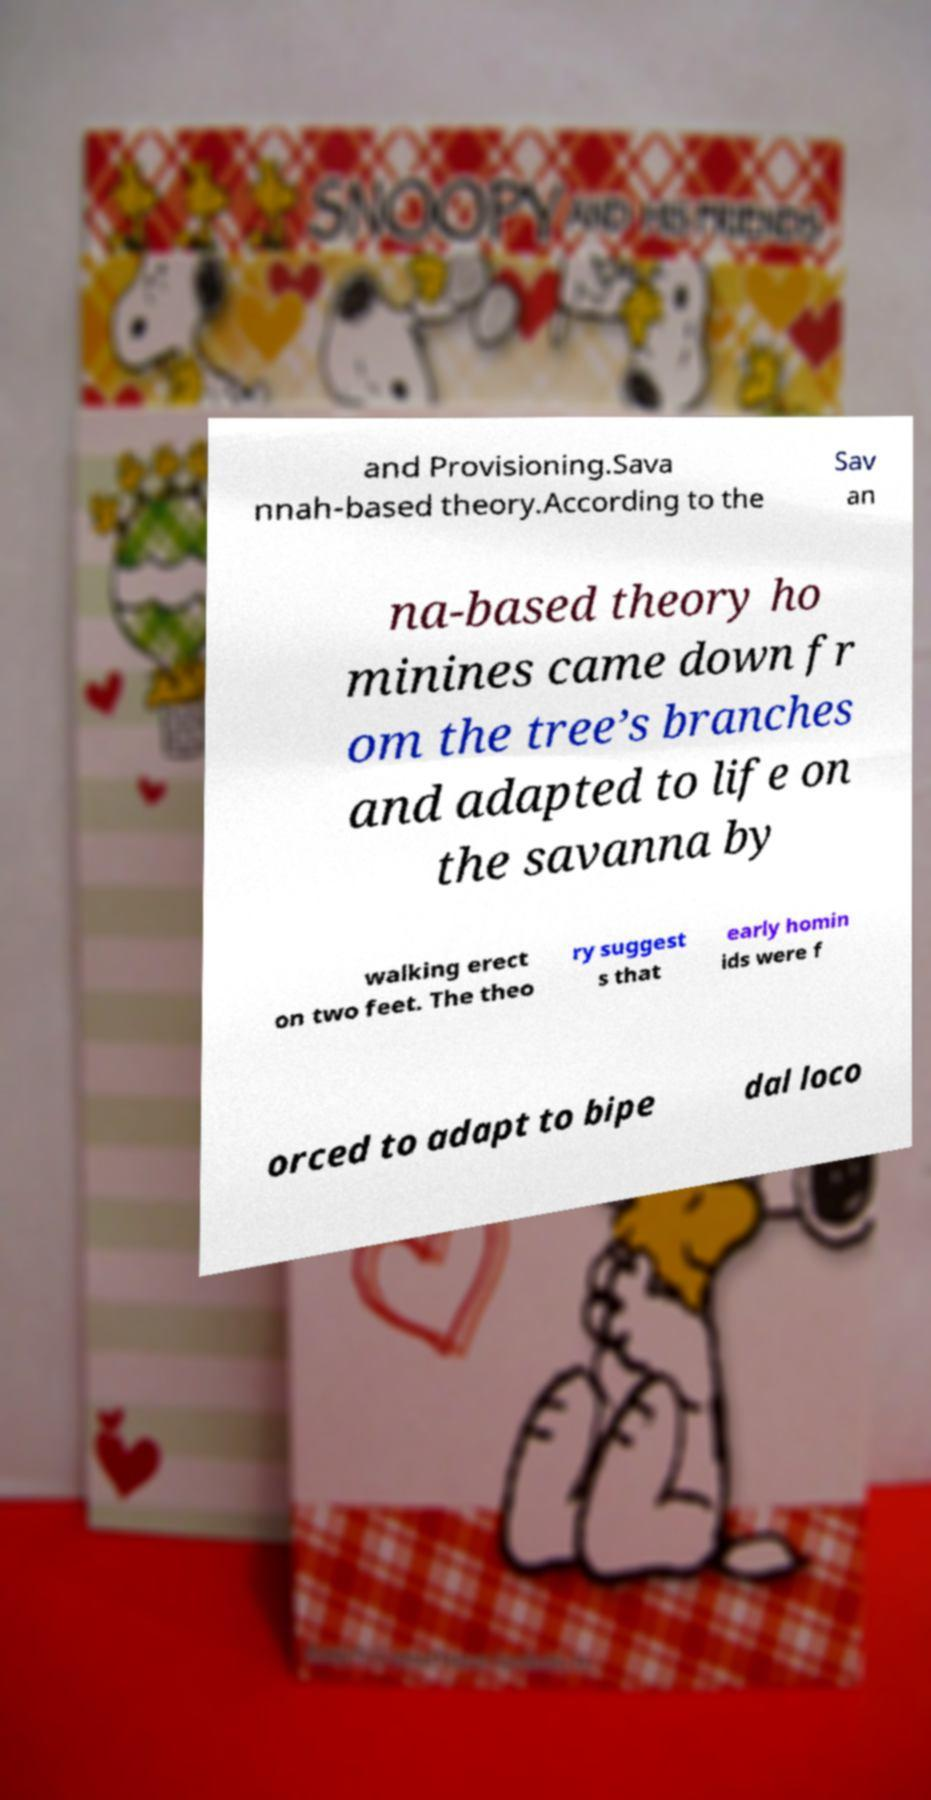Please identify and transcribe the text found in this image. and Provisioning.Sava nnah-based theory.According to the Sav an na-based theory ho minines came down fr om the tree’s branches and adapted to life on the savanna by walking erect on two feet. The theo ry suggest s that early homin ids were f orced to adapt to bipe dal loco 